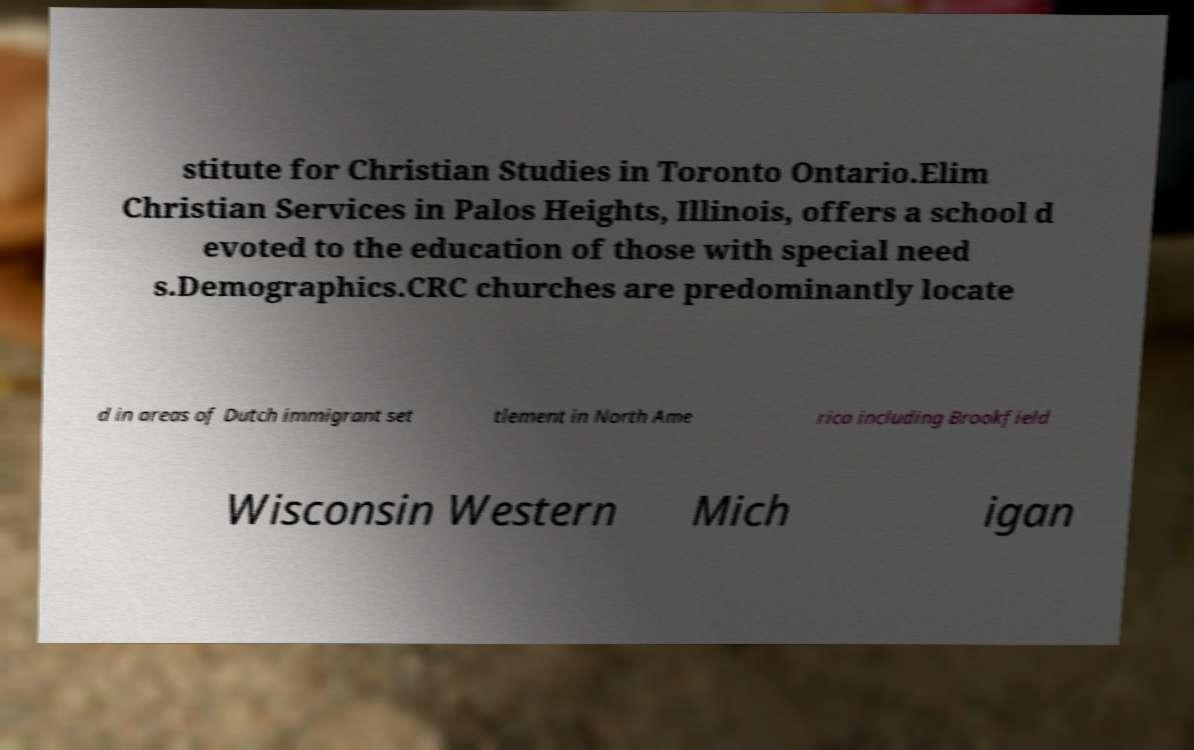Please read and relay the text visible in this image. What does it say? stitute for Christian Studies in Toronto Ontario.Elim Christian Services in Palos Heights, Illinois, offers a school d evoted to the education of those with special need s.Demographics.CRC churches are predominantly locate d in areas of Dutch immigrant set tlement in North Ame rica including Brookfield Wisconsin Western Mich igan 